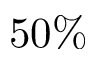Convert formula to latex. <formula><loc_0><loc_0><loc_500><loc_500>5 0 \%</formula> 